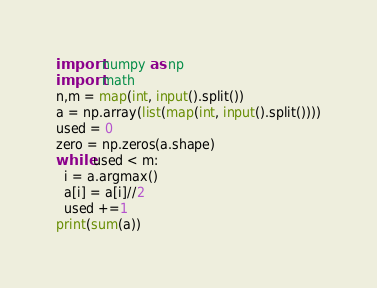Convert code to text. <code><loc_0><loc_0><loc_500><loc_500><_Python_>import numpy as np
import math
n,m = map(int, input().split())
a = np.array(list(map(int, input().split())))
used = 0
zero = np.zeros(a.shape)
while used < m:
  i = a.argmax()
  a[i] = a[i]//2
  used +=1
print(sum(a))</code> 